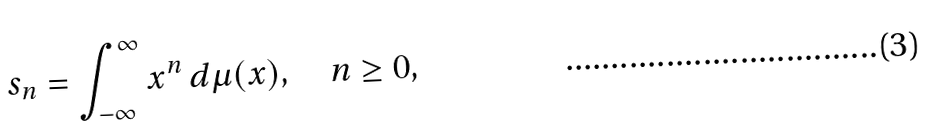Convert formula to latex. <formula><loc_0><loc_0><loc_500><loc_500>s _ { n } = \int _ { - \infty } ^ { \infty } x ^ { n } \, d \mu ( x ) , \quad n \geq 0 ,</formula> 